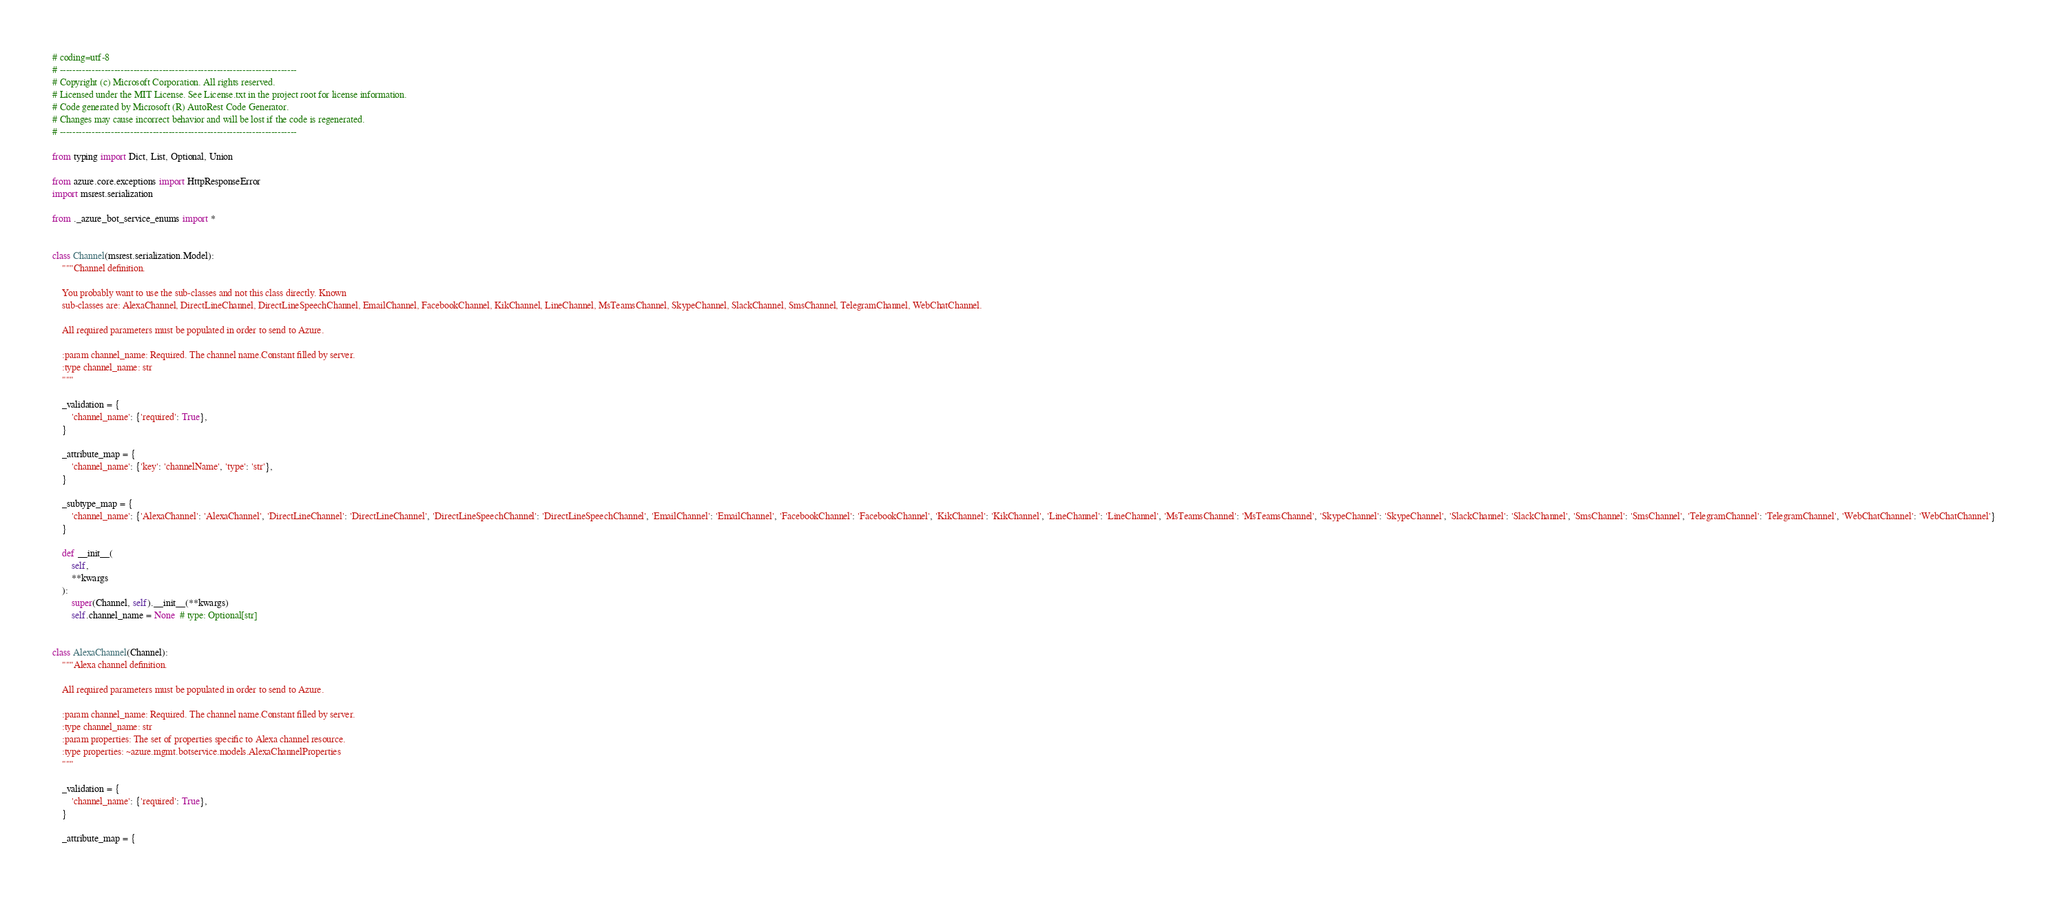Convert code to text. <code><loc_0><loc_0><loc_500><loc_500><_Python_># coding=utf-8
# --------------------------------------------------------------------------
# Copyright (c) Microsoft Corporation. All rights reserved.
# Licensed under the MIT License. See License.txt in the project root for license information.
# Code generated by Microsoft (R) AutoRest Code Generator.
# Changes may cause incorrect behavior and will be lost if the code is regenerated.
# --------------------------------------------------------------------------

from typing import Dict, List, Optional, Union

from azure.core.exceptions import HttpResponseError
import msrest.serialization

from ._azure_bot_service_enums import *


class Channel(msrest.serialization.Model):
    """Channel definition.

    You probably want to use the sub-classes and not this class directly. Known
    sub-classes are: AlexaChannel, DirectLineChannel, DirectLineSpeechChannel, EmailChannel, FacebookChannel, KikChannel, LineChannel, MsTeamsChannel, SkypeChannel, SlackChannel, SmsChannel, TelegramChannel, WebChatChannel.

    All required parameters must be populated in order to send to Azure.

    :param channel_name: Required. The channel name.Constant filled by server.
    :type channel_name: str
    """

    _validation = {
        'channel_name': {'required': True},
    }

    _attribute_map = {
        'channel_name': {'key': 'channelName', 'type': 'str'},
    }

    _subtype_map = {
        'channel_name': {'AlexaChannel': 'AlexaChannel', 'DirectLineChannel': 'DirectLineChannel', 'DirectLineSpeechChannel': 'DirectLineSpeechChannel', 'EmailChannel': 'EmailChannel', 'FacebookChannel': 'FacebookChannel', 'KikChannel': 'KikChannel', 'LineChannel': 'LineChannel', 'MsTeamsChannel': 'MsTeamsChannel', 'SkypeChannel': 'SkypeChannel', 'SlackChannel': 'SlackChannel', 'SmsChannel': 'SmsChannel', 'TelegramChannel': 'TelegramChannel', 'WebChatChannel': 'WebChatChannel'}
    }

    def __init__(
        self,
        **kwargs
    ):
        super(Channel, self).__init__(**kwargs)
        self.channel_name = None  # type: Optional[str]


class AlexaChannel(Channel):
    """Alexa channel definition.

    All required parameters must be populated in order to send to Azure.

    :param channel_name: Required. The channel name.Constant filled by server.
    :type channel_name: str
    :param properties: The set of properties specific to Alexa channel resource.
    :type properties: ~azure.mgmt.botservice.models.AlexaChannelProperties
    """

    _validation = {
        'channel_name': {'required': True},
    }

    _attribute_map = {</code> 